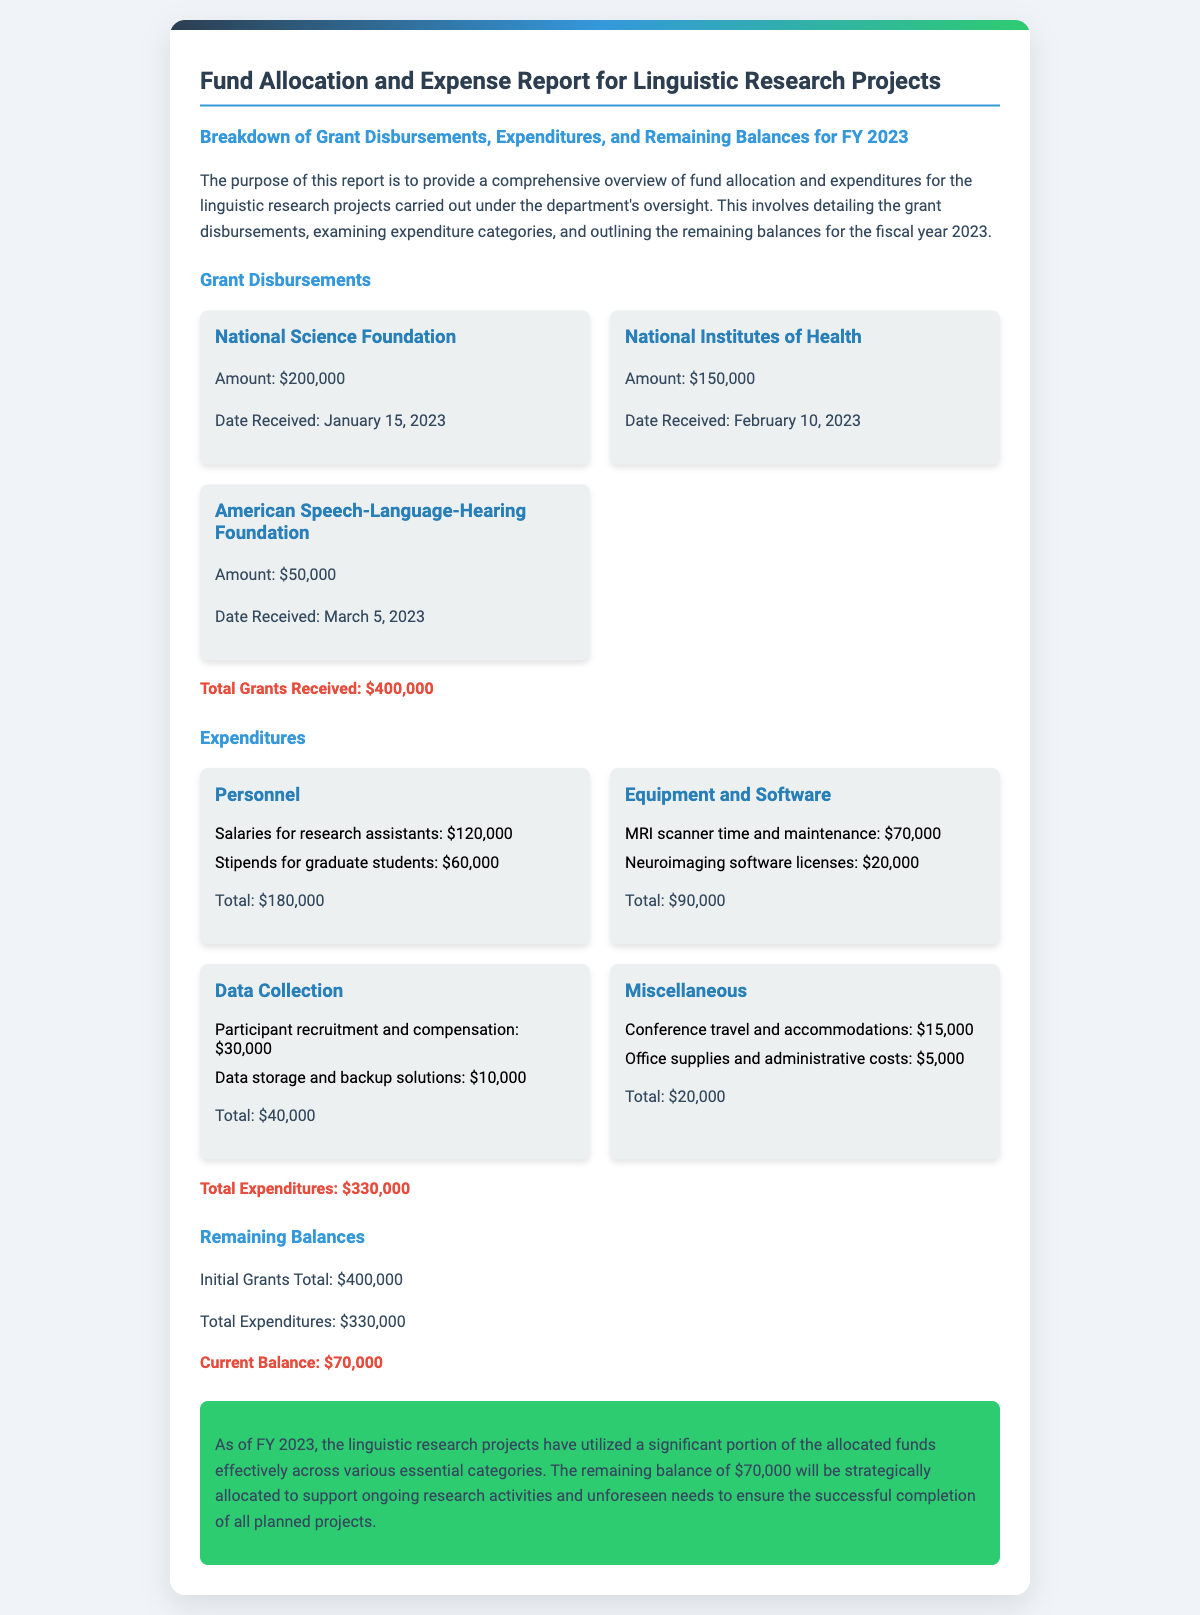what is the total amount of grants received? The total amount of grants received is presented clearly in the document, adding up all the individual grant amounts.
Answer: $400,000 what is the date when the National Institutes of Health grant was received? The specific date of the National Institutes of Health grant can be found in the section detailing grant disbursements.
Answer: February 10, 2023 how much was allocated for salaries for research assistants? This amount is detailed under the expenditures for the personnel category in the document.
Answer: $120,000 what is the total of equipment and software expenditures? The total for equipment and software expenditures is explicitly mentioned in the document after listing the individual costs.
Answer: $90,000 what is the remaining balance after expenditures? The current balance is calculated by subtracting total expenditures from the initial grants total, stated clearly in the remaining balances section.
Answer: $70,000 which organization provided the largest grant? The document lists the organizations along with their respective grant amounts, indicating which is the largest.
Answer: National Science Foundation what was the total expenditure for data collection? The total expenditure for data collection is provided in the expenditures section, summarizing its components.
Answer: $40,000 how much money was spent on conference travel and accommodations? This specific amount is found within the miscellaneous expenditures category in the document.
Answer: $15,000 what is the purpose of this report? The purpose of the report is explicitly stated in the introductory paragraph.
Answer: Provide a comprehensive overview of fund allocation and expenditures for the linguistic research projects 